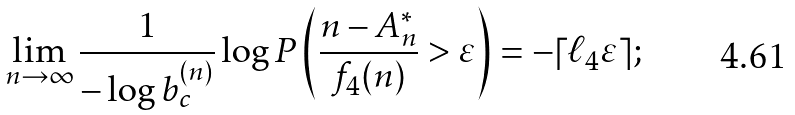Convert formula to latex. <formula><loc_0><loc_0><loc_500><loc_500>\lim _ { n \to \infty } \frac { 1 } { - \log b _ { c } ^ { ( n ) } } \log P \left ( \frac { n - A _ { n } ^ { * } } { f _ { 4 } ( n ) } > \varepsilon \right ) = - \lceil \ell _ { 4 } \varepsilon \rceil ;</formula> 